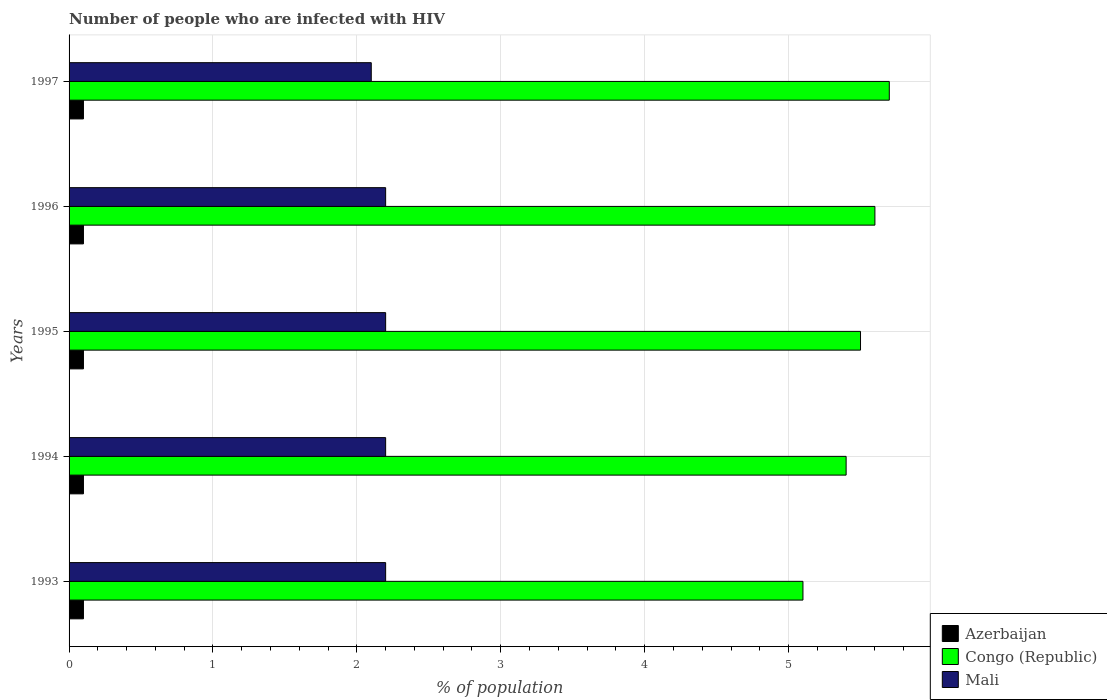How many groups of bars are there?
Offer a terse response. 5. Are the number of bars per tick equal to the number of legend labels?
Provide a short and direct response. Yes. How many bars are there on the 3rd tick from the top?
Your answer should be compact. 3. How many bars are there on the 5th tick from the bottom?
Keep it short and to the point. 3. In how many cases, is the number of bars for a given year not equal to the number of legend labels?
Keep it short and to the point. 0. What is the percentage of HIV infected population in in Azerbaijan in 1993?
Ensure brevity in your answer.  0.1. Across all years, what is the maximum percentage of HIV infected population in in Mali?
Make the answer very short. 2.2. In which year was the percentage of HIV infected population in in Congo (Republic) minimum?
Give a very brief answer. 1993. What is the difference between the percentage of HIV infected population in in Congo (Republic) in 1995 and that in 1997?
Provide a short and direct response. -0.2. What is the difference between the percentage of HIV infected population in in Mali in 1993 and the percentage of HIV infected population in in Azerbaijan in 1997?
Offer a very short reply. 2.1. What is the average percentage of HIV infected population in in Congo (Republic) per year?
Make the answer very short. 5.46. In the year 1993, what is the difference between the percentage of HIV infected population in in Azerbaijan and percentage of HIV infected population in in Congo (Republic)?
Your answer should be very brief. -5. Is the percentage of HIV infected population in in Azerbaijan in 1993 less than that in 1994?
Your answer should be very brief. No. In how many years, is the percentage of HIV infected population in in Congo (Republic) greater than the average percentage of HIV infected population in in Congo (Republic) taken over all years?
Provide a succinct answer. 3. What does the 3rd bar from the top in 1997 represents?
Provide a succinct answer. Azerbaijan. What does the 2nd bar from the bottom in 1996 represents?
Offer a very short reply. Congo (Republic). How many bars are there?
Make the answer very short. 15. How many years are there in the graph?
Your response must be concise. 5. Are the values on the major ticks of X-axis written in scientific E-notation?
Keep it short and to the point. No. Does the graph contain any zero values?
Make the answer very short. No. Where does the legend appear in the graph?
Your answer should be very brief. Bottom right. What is the title of the graph?
Ensure brevity in your answer.  Number of people who are infected with HIV. What is the label or title of the X-axis?
Your response must be concise. % of population. What is the % of population in Azerbaijan in 1993?
Provide a short and direct response. 0.1. What is the % of population in Congo (Republic) in 1993?
Offer a terse response. 5.1. What is the % of population of Congo (Republic) in 1994?
Provide a short and direct response. 5.4. What is the % of population of Congo (Republic) in 1995?
Keep it short and to the point. 5.5. What is the % of population in Mali in 1995?
Provide a short and direct response. 2.2. What is the % of population in Azerbaijan in 1996?
Provide a succinct answer. 0.1. What is the % of population in Mali in 1997?
Your answer should be compact. 2.1. Across all years, what is the maximum % of population of Azerbaijan?
Your answer should be very brief. 0.1. Across all years, what is the minimum % of population in Congo (Republic)?
Make the answer very short. 5.1. Across all years, what is the minimum % of population in Mali?
Provide a short and direct response. 2.1. What is the total % of population of Azerbaijan in the graph?
Keep it short and to the point. 0.5. What is the total % of population in Congo (Republic) in the graph?
Your response must be concise. 27.3. What is the difference between the % of population of Azerbaijan in 1993 and that in 1994?
Your answer should be very brief. 0. What is the difference between the % of population in Congo (Republic) in 1993 and that in 1994?
Make the answer very short. -0.3. What is the difference between the % of population of Mali in 1993 and that in 1994?
Ensure brevity in your answer.  0. What is the difference between the % of population in Azerbaijan in 1993 and that in 1995?
Make the answer very short. 0. What is the difference between the % of population of Azerbaijan in 1993 and that in 1996?
Your answer should be very brief. 0. What is the difference between the % of population in Mali in 1993 and that in 1996?
Offer a very short reply. 0. What is the difference between the % of population in Congo (Republic) in 1993 and that in 1997?
Ensure brevity in your answer.  -0.6. What is the difference between the % of population of Mali in 1993 and that in 1997?
Offer a very short reply. 0.1. What is the difference between the % of population in Congo (Republic) in 1994 and that in 1995?
Make the answer very short. -0.1. What is the difference between the % of population of Mali in 1994 and that in 1995?
Provide a short and direct response. 0. What is the difference between the % of population of Azerbaijan in 1994 and that in 1996?
Offer a very short reply. 0. What is the difference between the % of population of Congo (Republic) in 1994 and that in 1996?
Ensure brevity in your answer.  -0.2. What is the difference between the % of population of Azerbaijan in 1994 and that in 1997?
Give a very brief answer. 0. What is the difference between the % of population in Azerbaijan in 1995 and that in 1996?
Keep it short and to the point. 0. What is the difference between the % of population in Congo (Republic) in 1995 and that in 1996?
Your answer should be compact. -0.1. What is the difference between the % of population of Azerbaijan in 1995 and that in 1997?
Give a very brief answer. 0. What is the difference between the % of population in Congo (Republic) in 1996 and that in 1997?
Ensure brevity in your answer.  -0.1. What is the difference between the % of population of Mali in 1996 and that in 1997?
Make the answer very short. 0.1. What is the difference between the % of population in Congo (Republic) in 1993 and the % of population in Mali in 1994?
Give a very brief answer. 2.9. What is the difference between the % of population in Azerbaijan in 1993 and the % of population in Congo (Republic) in 1995?
Provide a succinct answer. -5.4. What is the difference between the % of population in Azerbaijan in 1993 and the % of population in Congo (Republic) in 1996?
Provide a short and direct response. -5.5. What is the difference between the % of population of Congo (Republic) in 1993 and the % of population of Mali in 1996?
Give a very brief answer. 2.9. What is the difference between the % of population in Azerbaijan in 1993 and the % of population in Mali in 1997?
Give a very brief answer. -2. What is the difference between the % of population of Congo (Republic) in 1993 and the % of population of Mali in 1997?
Keep it short and to the point. 3. What is the difference between the % of population in Azerbaijan in 1994 and the % of population in Congo (Republic) in 1995?
Give a very brief answer. -5.4. What is the difference between the % of population of Azerbaijan in 1994 and the % of population of Mali in 1995?
Your response must be concise. -2.1. What is the difference between the % of population in Congo (Republic) in 1994 and the % of population in Mali in 1996?
Your answer should be very brief. 3.2. What is the difference between the % of population of Azerbaijan in 1995 and the % of population of Congo (Republic) in 1996?
Make the answer very short. -5.5. What is the difference between the % of population of Congo (Republic) in 1995 and the % of population of Mali in 1997?
Provide a short and direct response. 3.4. What is the difference between the % of population of Congo (Republic) in 1996 and the % of population of Mali in 1997?
Your answer should be compact. 3.5. What is the average % of population in Congo (Republic) per year?
Provide a short and direct response. 5.46. What is the average % of population of Mali per year?
Your response must be concise. 2.18. In the year 1994, what is the difference between the % of population of Azerbaijan and % of population of Congo (Republic)?
Give a very brief answer. -5.3. In the year 1994, what is the difference between the % of population in Azerbaijan and % of population in Mali?
Your answer should be compact. -2.1. In the year 1995, what is the difference between the % of population of Azerbaijan and % of population of Congo (Republic)?
Keep it short and to the point. -5.4. In the year 1995, what is the difference between the % of population in Congo (Republic) and % of population in Mali?
Your response must be concise. 3.3. In the year 1996, what is the difference between the % of population in Azerbaijan and % of population in Congo (Republic)?
Your answer should be very brief. -5.5. In the year 1996, what is the difference between the % of population of Congo (Republic) and % of population of Mali?
Your answer should be compact. 3.4. In the year 1997, what is the difference between the % of population of Azerbaijan and % of population of Congo (Republic)?
Offer a terse response. -5.6. In the year 1997, what is the difference between the % of population of Congo (Republic) and % of population of Mali?
Provide a short and direct response. 3.6. What is the ratio of the % of population of Congo (Republic) in 1993 to that in 1994?
Give a very brief answer. 0.94. What is the ratio of the % of population of Mali in 1993 to that in 1994?
Your answer should be compact. 1. What is the ratio of the % of population of Congo (Republic) in 1993 to that in 1995?
Your answer should be compact. 0.93. What is the ratio of the % of population in Mali in 1993 to that in 1995?
Make the answer very short. 1. What is the ratio of the % of population of Azerbaijan in 1993 to that in 1996?
Keep it short and to the point. 1. What is the ratio of the % of population of Congo (Republic) in 1993 to that in 1996?
Make the answer very short. 0.91. What is the ratio of the % of population in Azerbaijan in 1993 to that in 1997?
Make the answer very short. 1. What is the ratio of the % of population in Congo (Republic) in 1993 to that in 1997?
Your answer should be compact. 0.89. What is the ratio of the % of population in Mali in 1993 to that in 1997?
Make the answer very short. 1.05. What is the ratio of the % of population of Congo (Republic) in 1994 to that in 1995?
Provide a short and direct response. 0.98. What is the ratio of the % of population of Mali in 1994 to that in 1995?
Provide a succinct answer. 1. What is the ratio of the % of population of Azerbaijan in 1994 to that in 1996?
Provide a succinct answer. 1. What is the ratio of the % of population in Congo (Republic) in 1994 to that in 1996?
Your answer should be compact. 0.96. What is the ratio of the % of population in Mali in 1994 to that in 1997?
Ensure brevity in your answer.  1.05. What is the ratio of the % of population in Azerbaijan in 1995 to that in 1996?
Provide a succinct answer. 1. What is the ratio of the % of population of Congo (Republic) in 1995 to that in 1996?
Your response must be concise. 0.98. What is the ratio of the % of population in Mali in 1995 to that in 1996?
Offer a very short reply. 1. What is the ratio of the % of population of Azerbaijan in 1995 to that in 1997?
Your response must be concise. 1. What is the ratio of the % of population of Congo (Republic) in 1995 to that in 1997?
Ensure brevity in your answer.  0.96. What is the ratio of the % of population in Mali in 1995 to that in 1997?
Your answer should be compact. 1.05. What is the ratio of the % of population in Azerbaijan in 1996 to that in 1997?
Make the answer very short. 1. What is the ratio of the % of population in Congo (Republic) in 1996 to that in 1997?
Make the answer very short. 0.98. What is the ratio of the % of population of Mali in 1996 to that in 1997?
Give a very brief answer. 1.05. What is the difference between the highest and the second highest % of population of Congo (Republic)?
Provide a succinct answer. 0.1. What is the difference between the highest and the second highest % of population of Mali?
Your answer should be very brief. 0. What is the difference between the highest and the lowest % of population in Azerbaijan?
Offer a very short reply. 0. What is the difference between the highest and the lowest % of population of Mali?
Give a very brief answer. 0.1. 